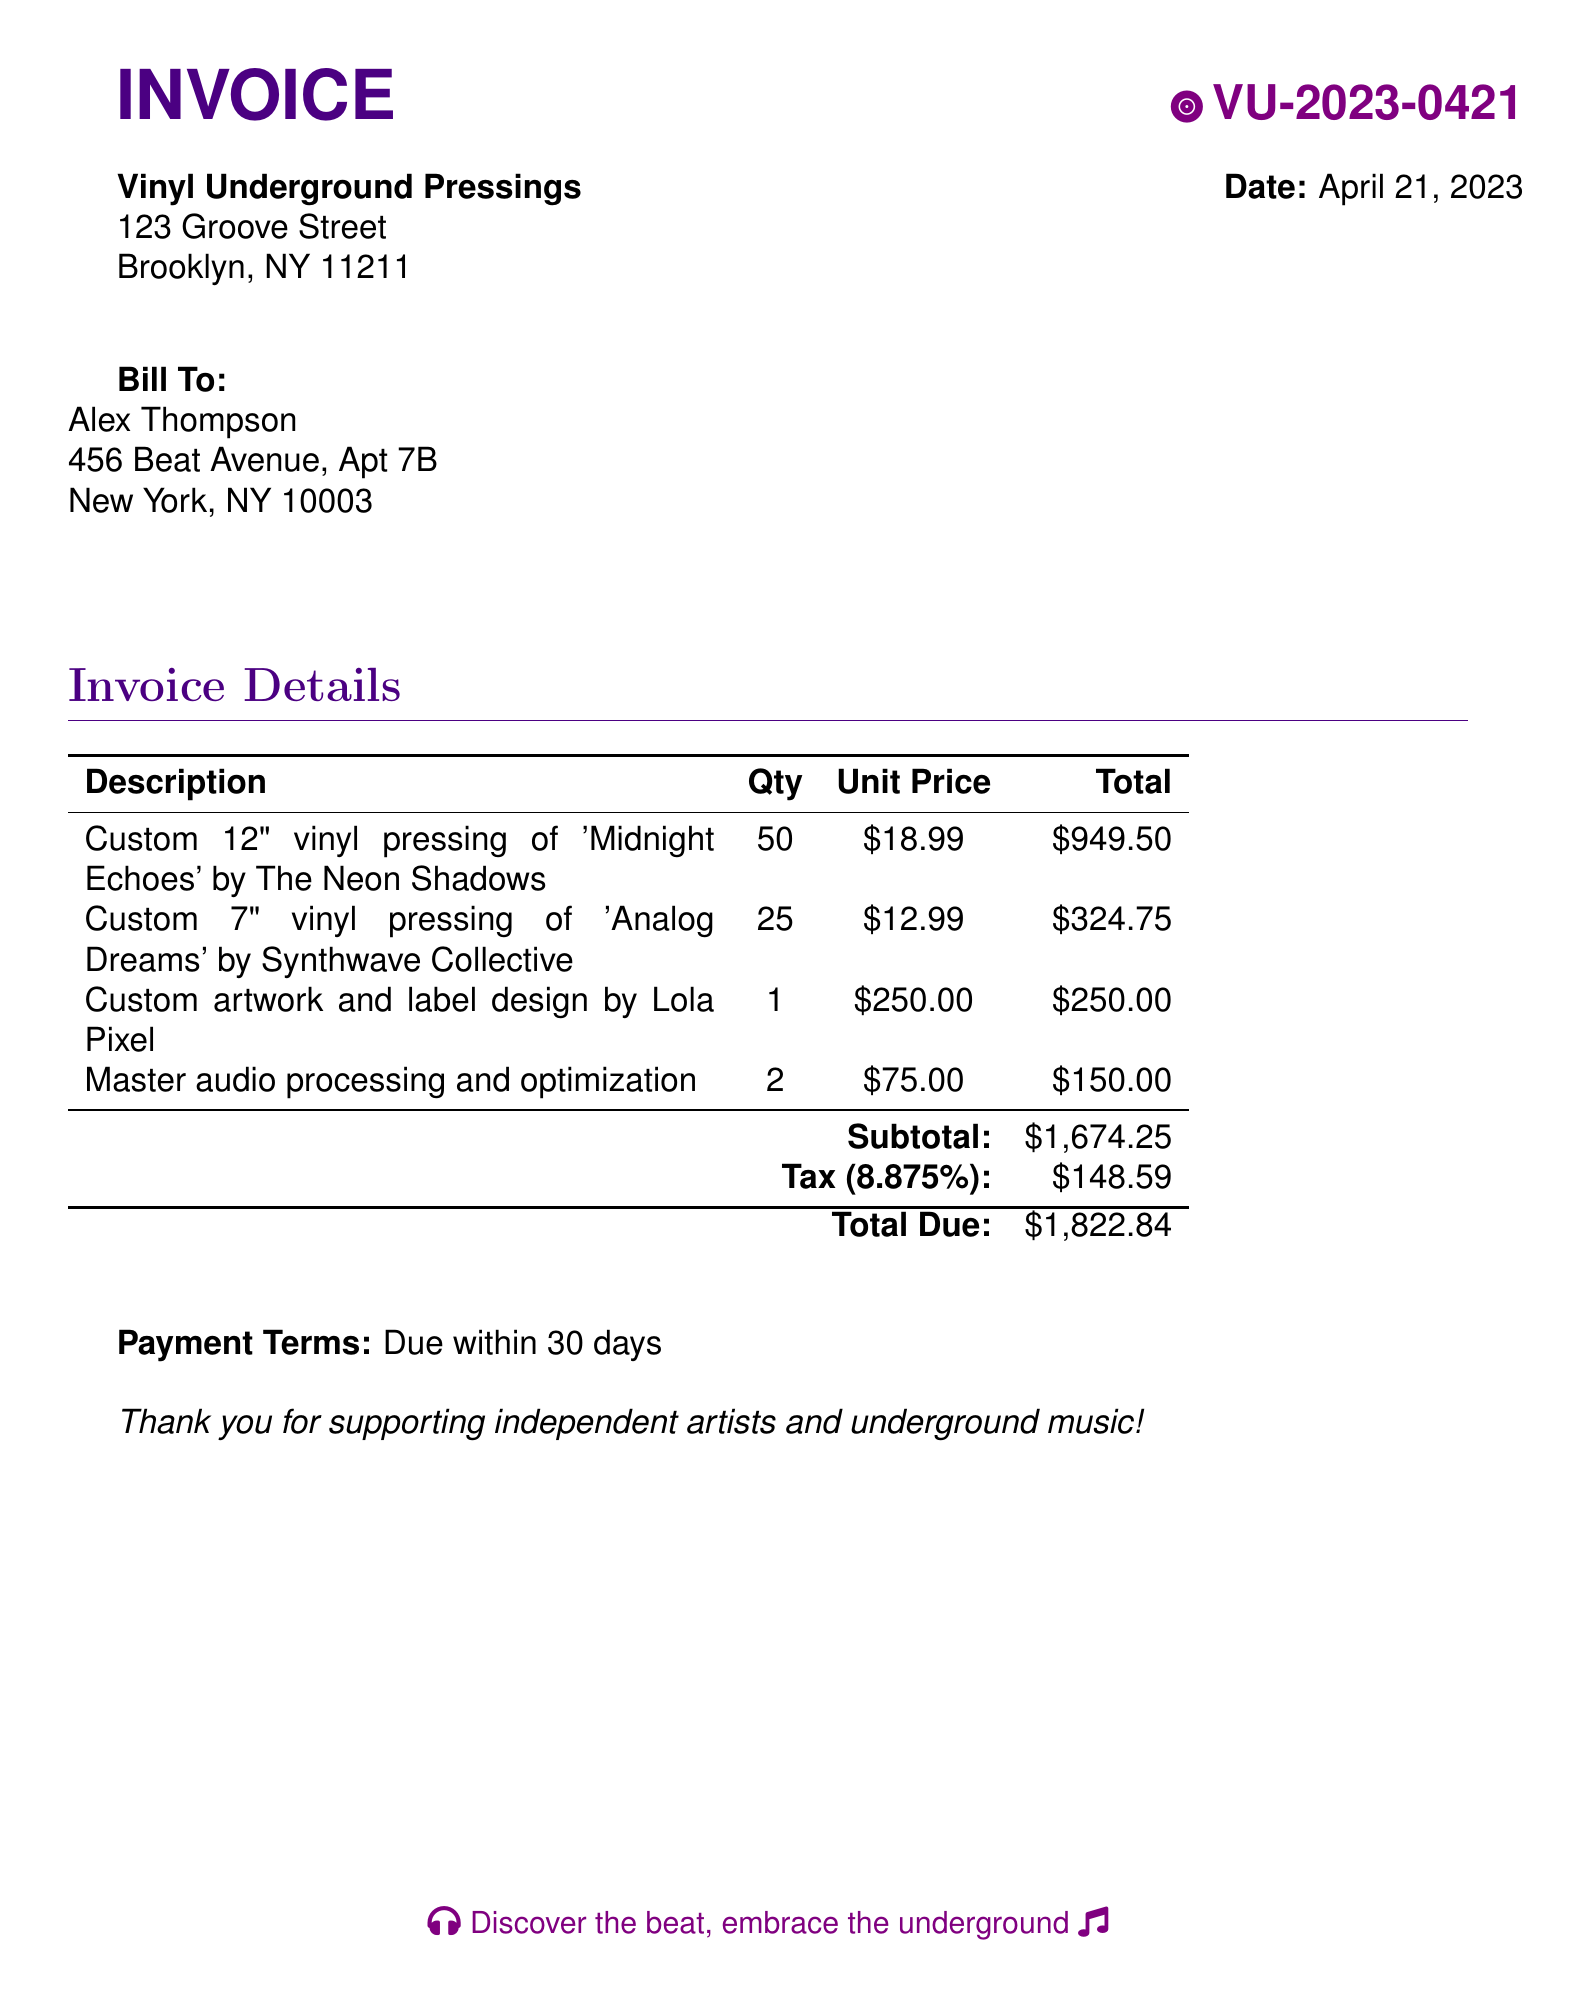What is the invoice number? The invoice number is identified in the document, specifically formatted as VU-2023-0421.
Answer: VU-2023-0421 What is the total due amount? The total due amount is listed clearly at the end of the invoice, which is $1,822.84.
Answer: $1,822.84 Who is the bill to? The document specifies the name of the person being billed, which is Alex Thompson.
Answer: Alex Thompson What is the date of the invoice? The invoice indicates the date when it was issued, which is April 21, 2023.
Answer: April 21, 2023 What is the subtotal before tax? The subtotal before tax is provided in the invoice and is calculated as $1,674.25.
Answer: $1,674.25 How many vinyl records of 'Analog Dreams' were pressed? The invoice details show the quantity of this specific vinyl pressing, which is 25.
Answer: 25 What is the unit price for custom artwork and label design? The invoice states the unit price for this service as $250.00.
Answer: $250.00 What percentage is the tax applied? The tax rate applied on the total is detailed as 8.875%.
Answer: 8.875% What is the payment term stated in the document? The payment term is mentioned clearly as due within 30 days.
Answer: Due within 30 days 